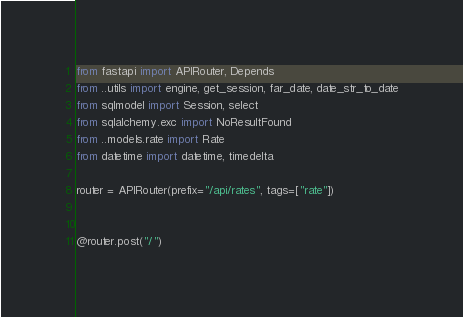<code> <loc_0><loc_0><loc_500><loc_500><_Python_>from fastapi import APIRouter, Depends
from ..utils import engine, get_session, far_date, date_str_to_date
from sqlmodel import Session, select
from sqlalchemy.exc import NoResultFound
from ..models.rate import Rate
from datetime import datetime, timedelta

router = APIRouter(prefix="/api/rates", tags=["rate"])


@router.post("/")</code> 